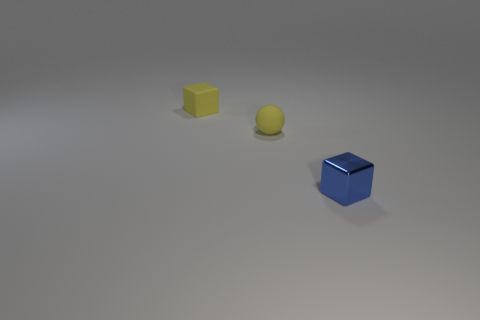Are there any big blue rubber objects that have the same shape as the small blue metal object?
Ensure brevity in your answer.  No. Is the number of tiny rubber objects less than the number of purple cubes?
Give a very brief answer. No. How many objects are tiny yellow objects or cubes to the left of the metal object?
Make the answer very short. 2. What number of yellow matte blocks are there?
Offer a terse response. 1. Is there a blue metallic object of the same size as the metal block?
Provide a short and direct response. No. Is the number of small yellow blocks in front of the small blue thing less than the number of matte spheres?
Your answer should be compact. Yes. Is the size of the blue shiny thing the same as the ball?
Give a very brief answer. Yes. There is a cube that is the same material as the tiny sphere; what size is it?
Your answer should be very brief. Small. What number of small things have the same color as the matte ball?
Your answer should be very brief. 1. Are there fewer blocks behind the shiny block than blocks that are right of the matte ball?
Make the answer very short. No. 